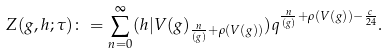Convert formula to latex. <formula><loc_0><loc_0><loc_500><loc_500>Z ( g , h ; \tau ) \colon = \sum _ { n = 0 } ^ { \infty } ( h | V ( g ) _ { \frac { n } { ( g ) } + \rho ( V ( g ) ) } ) q ^ { \frac { n } { ( g ) } + \rho ( V ( g ) ) - \frac { c } { 2 4 } } .</formula> 